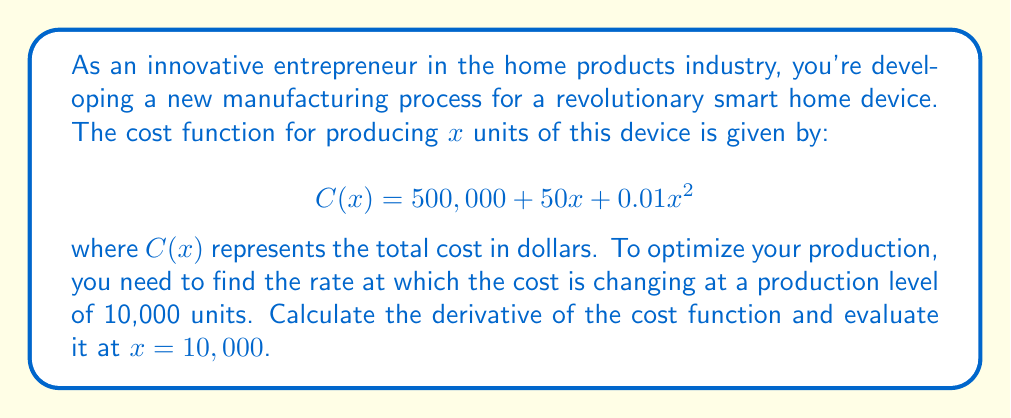What is the answer to this math problem? To solve this problem, we'll follow these steps:

1) First, let's find the derivative of the cost function $C(x)$.

   The cost function is:
   $$C(x) = 500,000 + 50x + 0.01x^2$$

   To find the derivative, we apply the sum rule and the power rule:

   - The derivative of a constant (500,000) is 0
   - The derivative of $50x$ is 50
   - The derivative of $0.01x^2$ is $2 \cdot 0.01x = 0.02x$

   Therefore, the derivative of $C(x)$ is:
   $$C'(x) = 0 + 50 + 0.02x = 50 + 0.02x$$

2) Now that we have the derivative, we need to evaluate it at $x = 10,000$.

   $$C'(10,000) = 50 + 0.02(10,000)$$

3) Let's calculate this:
   $$C'(10,000) = 50 + 200 = 250$$

The result, 250, represents the rate of change of the cost function at a production level of 10,000 units. This means that at this production level, the cost is increasing at a rate of $250 per unit.
Answer: The derivative of the cost function is $C'(x) = 50 + 0.02x$, and when evaluated at $x = 10,000$, the result is $C'(10,000) = 250$. 